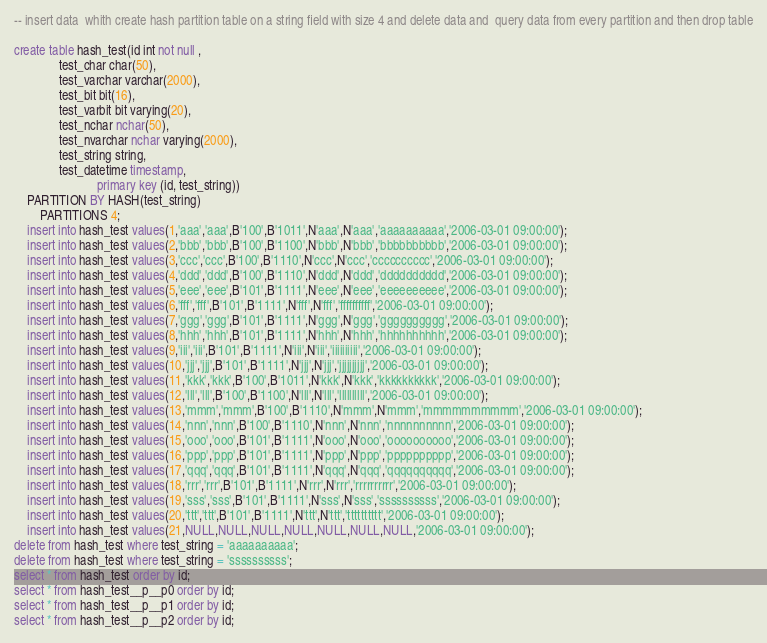Convert code to text. <code><loc_0><loc_0><loc_500><loc_500><_SQL_>-- insert data  whith create hash partition table on a string field with size 4 and delete data and  query data from every partition and then drop table

create table hash_test(id int not null ,
			  test_char char(50),
			  test_varchar varchar(2000),
			  test_bit bit(16),
			  test_varbit bit varying(20),
			  test_nchar nchar(50),
			  test_nvarchar nchar varying(2000),
			  test_string string,
			  test_datetime timestamp,
                          primary key (id, test_string))
	PARTITION BY HASH(test_string)
        PARTITIONS 4;
	insert into hash_test values(1,'aaa','aaa',B'100',B'1011',N'aaa',N'aaa','aaaaaaaaaa','2006-03-01 09:00:00');
	insert into hash_test values(2,'bbb','bbb',B'100',B'1100',N'bbb',N'bbb','bbbbbbbbbb','2006-03-01 09:00:00');
	insert into hash_test values(3,'ccc','ccc',B'100',B'1110',N'ccc',N'ccc','cccccccccc','2006-03-01 09:00:00');
	insert into hash_test values(4,'ddd','ddd',B'100',B'1110',N'ddd',N'ddd','dddddddddd','2006-03-01 09:00:00');
	insert into hash_test values(5,'eee','eee',B'101',B'1111',N'eee',N'eee','eeeeeeeeee','2006-03-01 09:00:00');
	insert into hash_test values(6,'fff','fff',B'101',B'1111',N'fff',N'fff','ffffffffff','2006-03-01 09:00:00');
	insert into hash_test values(7,'ggg','ggg',B'101',B'1111',N'ggg',N'ggg','gggggggggg','2006-03-01 09:00:00');
	insert into hash_test values(8,'hhh','hhh',B'101',B'1111',N'hhh',N'hhh','hhhhhhhhhh','2006-03-01 09:00:00');
	insert into hash_test values(9,'iii','iii',B'101',B'1111',N'iii',N'iii','iiiiiiiiii','2006-03-01 09:00:00');
	insert into hash_test values(10,'jjj','jjj',B'101',B'1111',N'jjj',N'jjj','jjjjjjjjjj','2006-03-01 09:00:00');
	insert into hash_test values(11,'kkk','kkk',B'100',B'1011',N'kkk',N'kkk','kkkkkkkkkk','2006-03-01 09:00:00');
	insert into hash_test values(12,'lll','lll',B'100',B'1100',N'lll',N'lll','llllllllll','2006-03-01 09:00:00');
	insert into hash_test values(13,'mmm','mmm',B'100',B'1110',N'mmm',N'mmm','mmmmmmmmmm','2006-03-01 09:00:00');
	insert into hash_test values(14,'nnn','nnn',B'100',B'1110',N'nnn',N'nnn','nnnnnnnnnn','2006-03-01 09:00:00');
	insert into hash_test values(15,'ooo','ooo',B'101',B'1111',N'ooo',N'ooo','oooooooooo','2006-03-01 09:00:00');
	insert into hash_test values(16,'ppp','ppp',B'101',B'1111',N'ppp',N'ppp','pppppppppp','2006-03-01 09:00:00');
	insert into hash_test values(17,'qqq','qqq',B'101',B'1111',N'qqq',N'qqq','qqqqqqqqqq','2006-03-01 09:00:00');
	insert into hash_test values(18,'rrr','rrr',B'101',B'1111',N'rrr',N'rrr','rrrrrrrrrr','2006-03-01 09:00:00');
	insert into hash_test values(19,'sss','sss',B'101',B'1111',N'sss',N'sss','ssssssssss','2006-03-01 09:00:00');
	insert into hash_test values(20,'ttt','ttt',B'101',B'1111',N'ttt',N'ttt','tttttttttt','2006-03-01 09:00:00');
	insert into hash_test values(21,NULL,NULL,NULL,NULL,NULL,NULL,NULL,'2006-03-01 09:00:00');
delete from hash_test where test_string = 'aaaaaaaaaa';
delete from hash_test where test_string = 'ssssssssss';
select * from hash_test order by id;
select * from hash_test__p__p0 order by id;
select * from hash_test__p__p1 order by id;
select * from hash_test__p__p2 order by id;</code> 